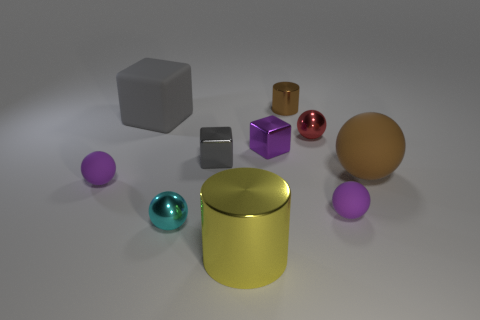What color is the tiny cylinder?
Keep it short and to the point. Brown. Are there more tiny cylinders in front of the cyan metal ball than brown things?
Your response must be concise. No. There is a small cyan metal thing; how many metal things are in front of it?
Offer a very short reply. 1. There is a tiny metal thing that is the same color as the large matte ball; what shape is it?
Your answer should be compact. Cylinder. There is a purple thing behind the big rubber thing that is in front of the big gray thing; is there a red object that is behind it?
Offer a terse response. Yes. Does the gray matte block have the same size as the brown matte sphere?
Ensure brevity in your answer.  Yes. Is the number of tiny purple cubes behind the brown metallic thing the same as the number of small purple objects to the right of the red metal object?
Your answer should be very brief. No. What is the shape of the purple matte thing right of the tiny cyan sphere?
Give a very brief answer. Sphere. The gray object that is the same size as the yellow shiny object is what shape?
Provide a short and direct response. Cube. The small rubber thing that is behind the purple ball on the right side of the shiny object that is behind the tiny red shiny thing is what color?
Offer a very short reply. Purple. 